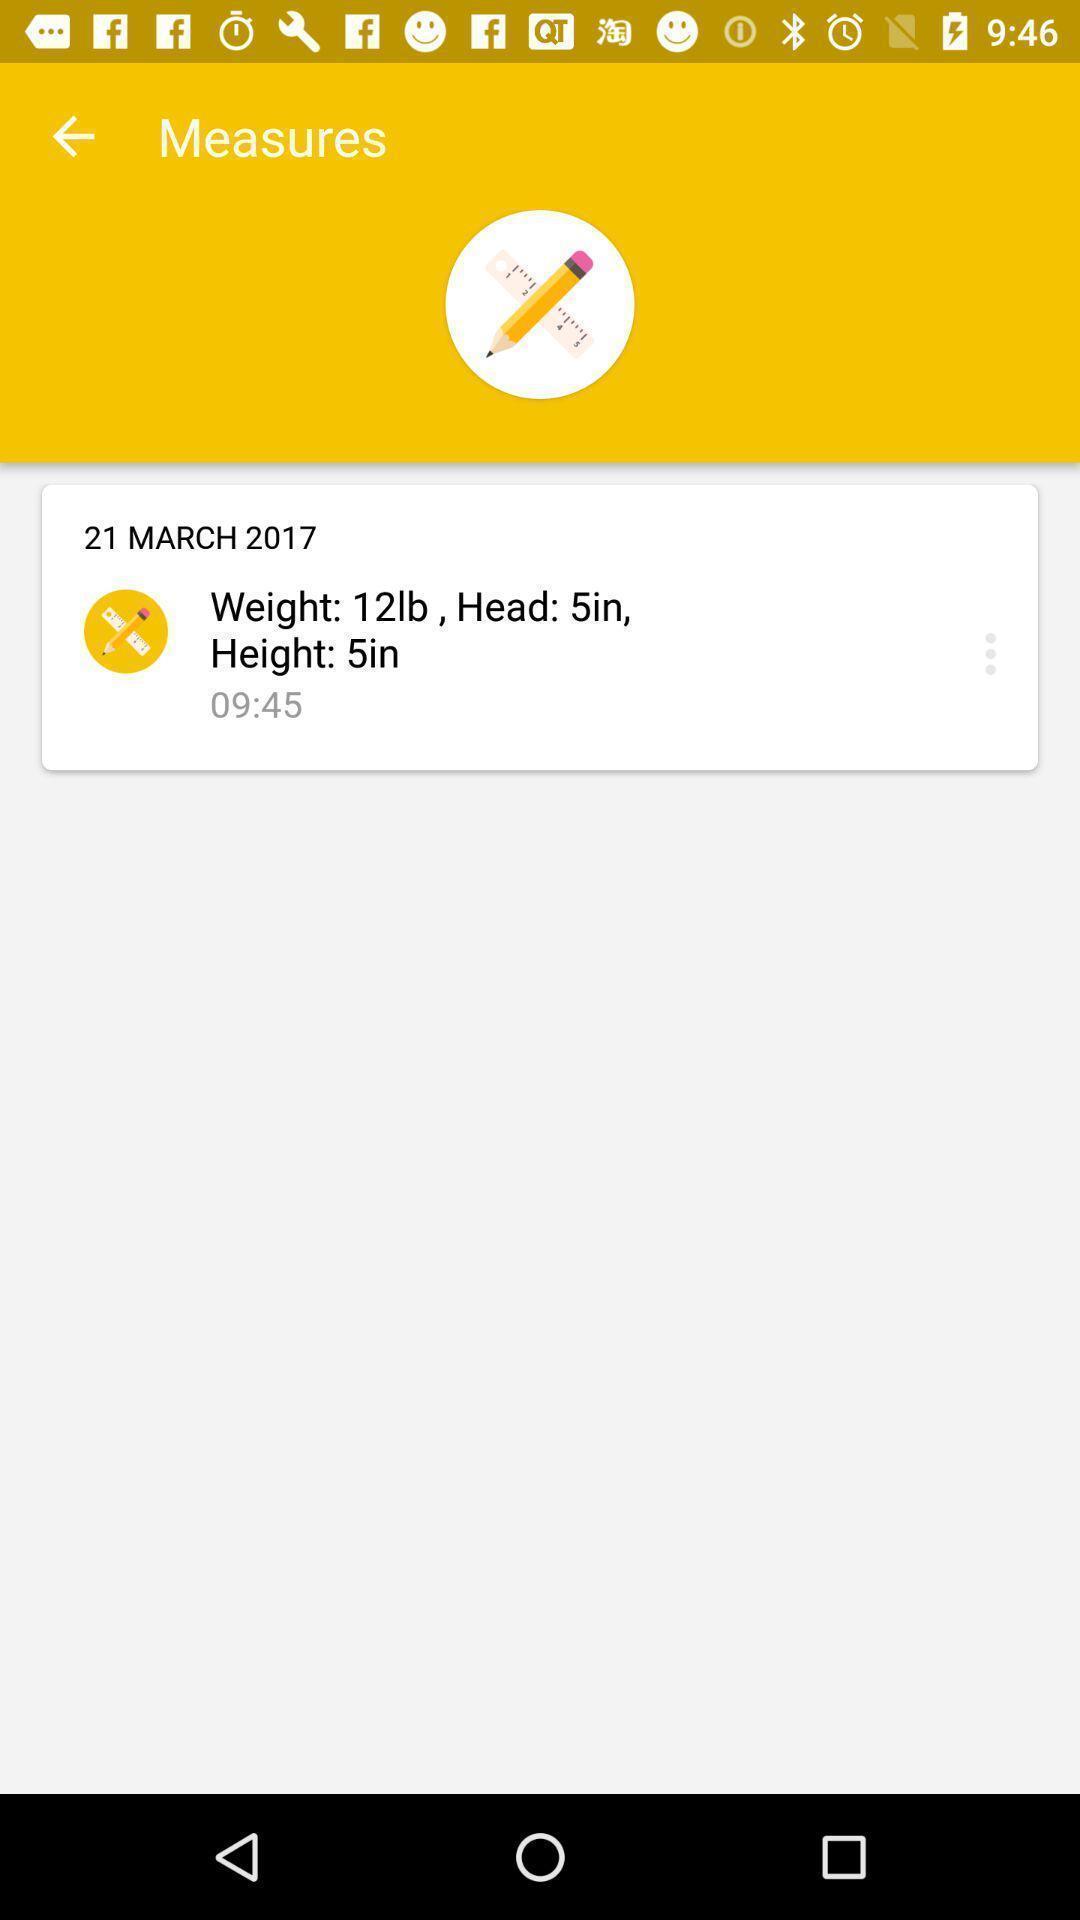What details can you identify in this image? Screen displaying the measures page. 